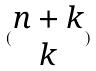Convert formula to latex. <formula><loc_0><loc_0><loc_500><loc_500>( \begin{matrix} n + k \\ k \end{matrix} )</formula> 